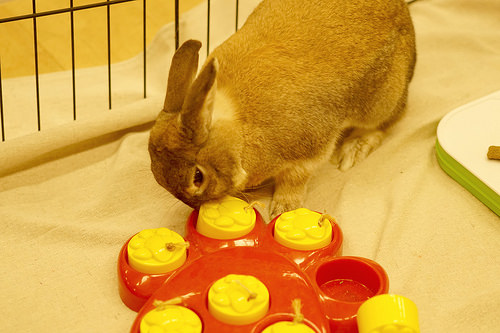<image>
Can you confirm if the block is on the plate? No. The block is not positioned on the plate. They may be near each other, but the block is not supported by or resting on top of the plate. 